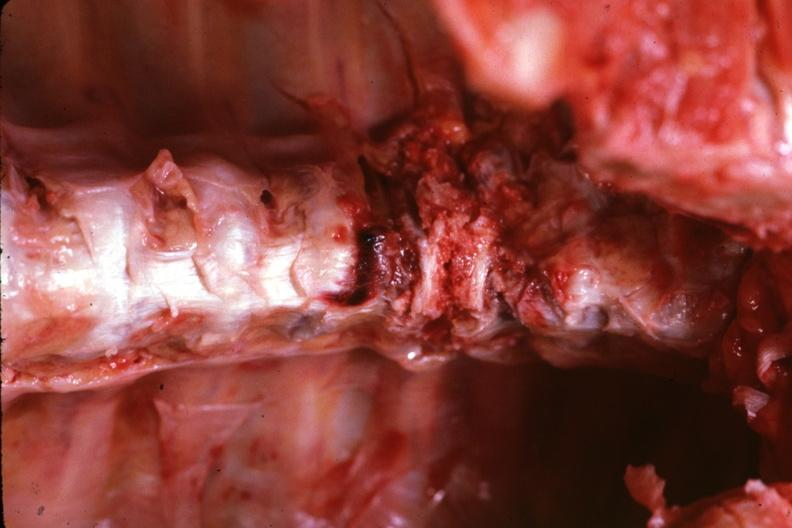does this image show in situ close-up view very good lower cervical?
Answer the question using a single word or phrase. Yes 